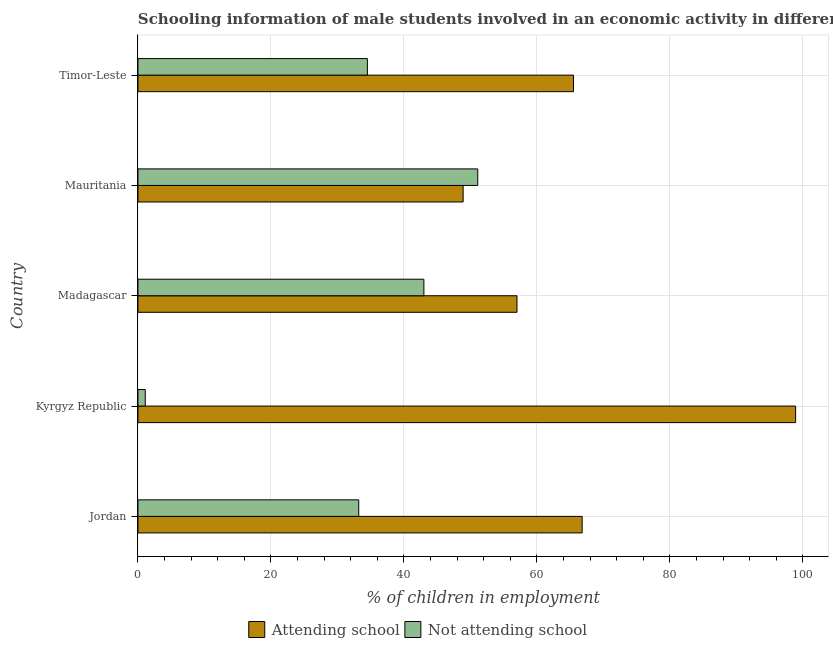How many different coloured bars are there?
Your response must be concise. 2. Are the number of bars per tick equal to the number of legend labels?
Offer a terse response. Yes. How many bars are there on the 3rd tick from the bottom?
Your response must be concise. 2. What is the label of the 1st group of bars from the top?
Make the answer very short. Timor-Leste. In how many cases, is the number of bars for a given country not equal to the number of legend labels?
Keep it short and to the point. 0. What is the percentage of employed males who are attending school in Timor-Leste?
Your answer should be compact. 65.5. Across all countries, what is the maximum percentage of employed males who are attending school?
Give a very brief answer. 98.9. Across all countries, what is the minimum percentage of employed males who are not attending school?
Your response must be concise. 1.1. In which country was the percentage of employed males who are not attending school maximum?
Provide a succinct answer. Mauritania. In which country was the percentage of employed males who are not attending school minimum?
Keep it short and to the point. Kyrgyz Republic. What is the total percentage of employed males who are not attending school in the graph?
Provide a short and direct response. 162.9. What is the difference between the percentage of employed males who are attending school in Jordan and that in Kyrgyz Republic?
Ensure brevity in your answer.  -32.1. What is the difference between the percentage of employed males who are not attending school in Madagascar and the percentage of employed males who are attending school in Timor-Leste?
Your answer should be compact. -22.5. What is the average percentage of employed males who are attending school per country?
Your response must be concise. 67.42. What is the difference between the percentage of employed males who are attending school and percentage of employed males who are not attending school in Timor-Leste?
Offer a very short reply. 31. What is the ratio of the percentage of employed males who are attending school in Jordan to that in Madagascar?
Offer a very short reply. 1.17. Is the percentage of employed males who are not attending school in Mauritania less than that in Timor-Leste?
Give a very brief answer. No. Is the difference between the percentage of employed males who are attending school in Kyrgyz Republic and Madagascar greater than the difference between the percentage of employed males who are not attending school in Kyrgyz Republic and Madagascar?
Offer a terse response. Yes. What does the 2nd bar from the top in Timor-Leste represents?
Make the answer very short. Attending school. What does the 2nd bar from the bottom in Jordan represents?
Ensure brevity in your answer.  Not attending school. How many bars are there?
Ensure brevity in your answer.  10. Are all the bars in the graph horizontal?
Ensure brevity in your answer.  Yes. Are the values on the major ticks of X-axis written in scientific E-notation?
Provide a succinct answer. No. Where does the legend appear in the graph?
Provide a succinct answer. Bottom center. How many legend labels are there?
Your answer should be very brief. 2. What is the title of the graph?
Provide a short and direct response. Schooling information of male students involved in an economic activity in different countries. What is the label or title of the X-axis?
Keep it short and to the point. % of children in employment. What is the % of children in employment of Attending school in Jordan?
Your answer should be very brief. 66.8. What is the % of children in employment of Not attending school in Jordan?
Make the answer very short. 33.2. What is the % of children in employment of Attending school in Kyrgyz Republic?
Give a very brief answer. 98.9. What is the % of children in employment in Attending school in Mauritania?
Your answer should be very brief. 48.9. What is the % of children in employment of Not attending school in Mauritania?
Make the answer very short. 51.1. What is the % of children in employment in Attending school in Timor-Leste?
Provide a succinct answer. 65.5. What is the % of children in employment of Not attending school in Timor-Leste?
Your response must be concise. 34.5. Across all countries, what is the maximum % of children in employment in Attending school?
Ensure brevity in your answer.  98.9. Across all countries, what is the maximum % of children in employment of Not attending school?
Provide a short and direct response. 51.1. Across all countries, what is the minimum % of children in employment of Attending school?
Keep it short and to the point. 48.9. Across all countries, what is the minimum % of children in employment of Not attending school?
Make the answer very short. 1.1. What is the total % of children in employment in Attending school in the graph?
Provide a short and direct response. 337.1. What is the total % of children in employment of Not attending school in the graph?
Your response must be concise. 162.9. What is the difference between the % of children in employment in Attending school in Jordan and that in Kyrgyz Republic?
Make the answer very short. -32.1. What is the difference between the % of children in employment in Not attending school in Jordan and that in Kyrgyz Republic?
Keep it short and to the point. 32.1. What is the difference between the % of children in employment in Attending school in Jordan and that in Madagascar?
Keep it short and to the point. 9.8. What is the difference between the % of children in employment in Not attending school in Jordan and that in Mauritania?
Your answer should be compact. -17.9. What is the difference between the % of children in employment in Attending school in Kyrgyz Republic and that in Madagascar?
Provide a short and direct response. 41.9. What is the difference between the % of children in employment in Not attending school in Kyrgyz Republic and that in Madagascar?
Your answer should be very brief. -41.9. What is the difference between the % of children in employment in Attending school in Kyrgyz Republic and that in Mauritania?
Your response must be concise. 50. What is the difference between the % of children in employment in Not attending school in Kyrgyz Republic and that in Mauritania?
Provide a succinct answer. -50. What is the difference between the % of children in employment of Attending school in Kyrgyz Republic and that in Timor-Leste?
Your answer should be very brief. 33.4. What is the difference between the % of children in employment in Not attending school in Kyrgyz Republic and that in Timor-Leste?
Give a very brief answer. -33.4. What is the difference between the % of children in employment in Attending school in Madagascar and that in Mauritania?
Provide a succinct answer. 8.1. What is the difference between the % of children in employment in Attending school in Madagascar and that in Timor-Leste?
Give a very brief answer. -8.5. What is the difference between the % of children in employment in Attending school in Mauritania and that in Timor-Leste?
Your answer should be compact. -16.6. What is the difference between the % of children in employment in Attending school in Jordan and the % of children in employment in Not attending school in Kyrgyz Republic?
Your answer should be very brief. 65.7. What is the difference between the % of children in employment in Attending school in Jordan and the % of children in employment in Not attending school in Madagascar?
Ensure brevity in your answer.  23.8. What is the difference between the % of children in employment of Attending school in Jordan and the % of children in employment of Not attending school in Mauritania?
Provide a short and direct response. 15.7. What is the difference between the % of children in employment of Attending school in Jordan and the % of children in employment of Not attending school in Timor-Leste?
Give a very brief answer. 32.3. What is the difference between the % of children in employment in Attending school in Kyrgyz Republic and the % of children in employment in Not attending school in Madagascar?
Keep it short and to the point. 55.9. What is the difference between the % of children in employment of Attending school in Kyrgyz Republic and the % of children in employment of Not attending school in Mauritania?
Ensure brevity in your answer.  47.8. What is the difference between the % of children in employment in Attending school in Kyrgyz Republic and the % of children in employment in Not attending school in Timor-Leste?
Your answer should be compact. 64.4. What is the difference between the % of children in employment in Attending school in Madagascar and the % of children in employment in Not attending school in Timor-Leste?
Offer a terse response. 22.5. What is the difference between the % of children in employment of Attending school in Mauritania and the % of children in employment of Not attending school in Timor-Leste?
Make the answer very short. 14.4. What is the average % of children in employment in Attending school per country?
Your answer should be very brief. 67.42. What is the average % of children in employment of Not attending school per country?
Your answer should be very brief. 32.58. What is the difference between the % of children in employment of Attending school and % of children in employment of Not attending school in Jordan?
Offer a very short reply. 33.6. What is the difference between the % of children in employment of Attending school and % of children in employment of Not attending school in Kyrgyz Republic?
Ensure brevity in your answer.  97.8. What is the difference between the % of children in employment of Attending school and % of children in employment of Not attending school in Madagascar?
Provide a short and direct response. 14. What is the ratio of the % of children in employment in Attending school in Jordan to that in Kyrgyz Republic?
Provide a succinct answer. 0.68. What is the ratio of the % of children in employment in Not attending school in Jordan to that in Kyrgyz Republic?
Your response must be concise. 30.18. What is the ratio of the % of children in employment of Attending school in Jordan to that in Madagascar?
Provide a succinct answer. 1.17. What is the ratio of the % of children in employment of Not attending school in Jordan to that in Madagascar?
Your response must be concise. 0.77. What is the ratio of the % of children in employment of Attending school in Jordan to that in Mauritania?
Ensure brevity in your answer.  1.37. What is the ratio of the % of children in employment in Not attending school in Jordan to that in Mauritania?
Provide a short and direct response. 0.65. What is the ratio of the % of children in employment in Attending school in Jordan to that in Timor-Leste?
Your answer should be compact. 1.02. What is the ratio of the % of children in employment in Not attending school in Jordan to that in Timor-Leste?
Ensure brevity in your answer.  0.96. What is the ratio of the % of children in employment in Attending school in Kyrgyz Republic to that in Madagascar?
Your answer should be compact. 1.74. What is the ratio of the % of children in employment in Not attending school in Kyrgyz Republic to that in Madagascar?
Ensure brevity in your answer.  0.03. What is the ratio of the % of children in employment of Attending school in Kyrgyz Republic to that in Mauritania?
Your answer should be very brief. 2.02. What is the ratio of the % of children in employment in Not attending school in Kyrgyz Republic to that in Mauritania?
Ensure brevity in your answer.  0.02. What is the ratio of the % of children in employment in Attending school in Kyrgyz Republic to that in Timor-Leste?
Your response must be concise. 1.51. What is the ratio of the % of children in employment in Not attending school in Kyrgyz Republic to that in Timor-Leste?
Your response must be concise. 0.03. What is the ratio of the % of children in employment of Attending school in Madagascar to that in Mauritania?
Offer a terse response. 1.17. What is the ratio of the % of children in employment in Not attending school in Madagascar to that in Mauritania?
Keep it short and to the point. 0.84. What is the ratio of the % of children in employment of Attending school in Madagascar to that in Timor-Leste?
Offer a very short reply. 0.87. What is the ratio of the % of children in employment of Not attending school in Madagascar to that in Timor-Leste?
Ensure brevity in your answer.  1.25. What is the ratio of the % of children in employment in Attending school in Mauritania to that in Timor-Leste?
Provide a short and direct response. 0.75. What is the ratio of the % of children in employment of Not attending school in Mauritania to that in Timor-Leste?
Provide a short and direct response. 1.48. What is the difference between the highest and the second highest % of children in employment in Attending school?
Offer a terse response. 32.1. 